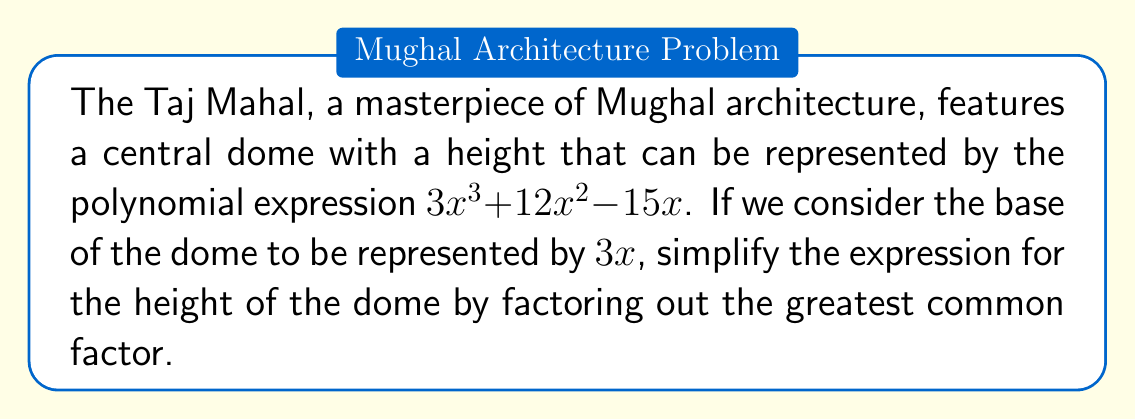Could you help me with this problem? To simplify this polynomial expression by factoring out the greatest common factor (GCF), we need to follow these steps:

1. Identify the terms in the polynomial:
   $3x^3$, $12x^2$, and $-15x$

2. Find the GCF of these terms:
   - The common factor of the coefficients is 3
   - The common variable factor is x with the lowest exponent (1)
   
   Therefore, the GCF is $3x$

3. Factor out the GCF:
   $$3x^3 + 12x^2 - 15x = 3x(x^2 + 4x - 5)$$

4. The remaining factor $(x^2 + 4x - 5)$ cannot be factored further, so our simplification is complete.

This simplified expression represents the height of the dome in terms of its base ($3x$) multiplied by a quadratic factor $(x^2 + 4x - 5)$, which might represent the curvature or proportional relationship of the dome's design.
Answer: $3x(x^2 + 4x - 5)$ 